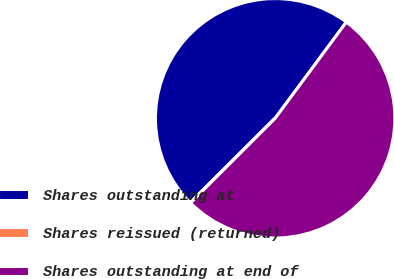<chart> <loc_0><loc_0><loc_500><loc_500><pie_chart><fcel>Shares outstanding at<fcel>Shares reissued (returned)<fcel>Shares outstanding at end of<nl><fcel>47.61%<fcel>0.03%<fcel>52.37%<nl></chart> 